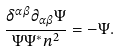Convert formula to latex. <formula><loc_0><loc_0><loc_500><loc_500>\frac { \delta ^ { \alpha \beta } \partial _ { \alpha \beta } \Psi } { \Psi \Psi ^ { * } n ^ { 2 } } = - \Psi .</formula> 